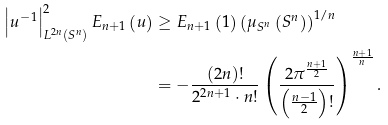<formula> <loc_0><loc_0><loc_500><loc_500>\left | u ^ { - 1 } \right | _ { L ^ { 2 n } \left ( S ^ { n } \right ) } ^ { 2 } E _ { n + 1 } \left ( u \right ) & \geq E _ { n + 1 } \left ( 1 \right ) \left ( \mu _ { S ^ { n } } \left ( S ^ { n } \right ) \right ) ^ { 1 / n } \\ & = - \frac { \left ( 2 n \right ) ! } { 2 ^ { 2 n + 1 } \cdot n ! } \left ( \frac { 2 \pi ^ { \frac { n + 1 } { 2 } } } { \left ( \frac { n - 1 } { 2 } \right ) ! } \right ) ^ { \frac { n + 1 } { n } } .</formula> 